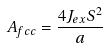Convert formula to latex. <formula><loc_0><loc_0><loc_500><loc_500>A _ { f c c } = \frac { 4 J _ { e x } S ^ { 2 } } { a }</formula> 